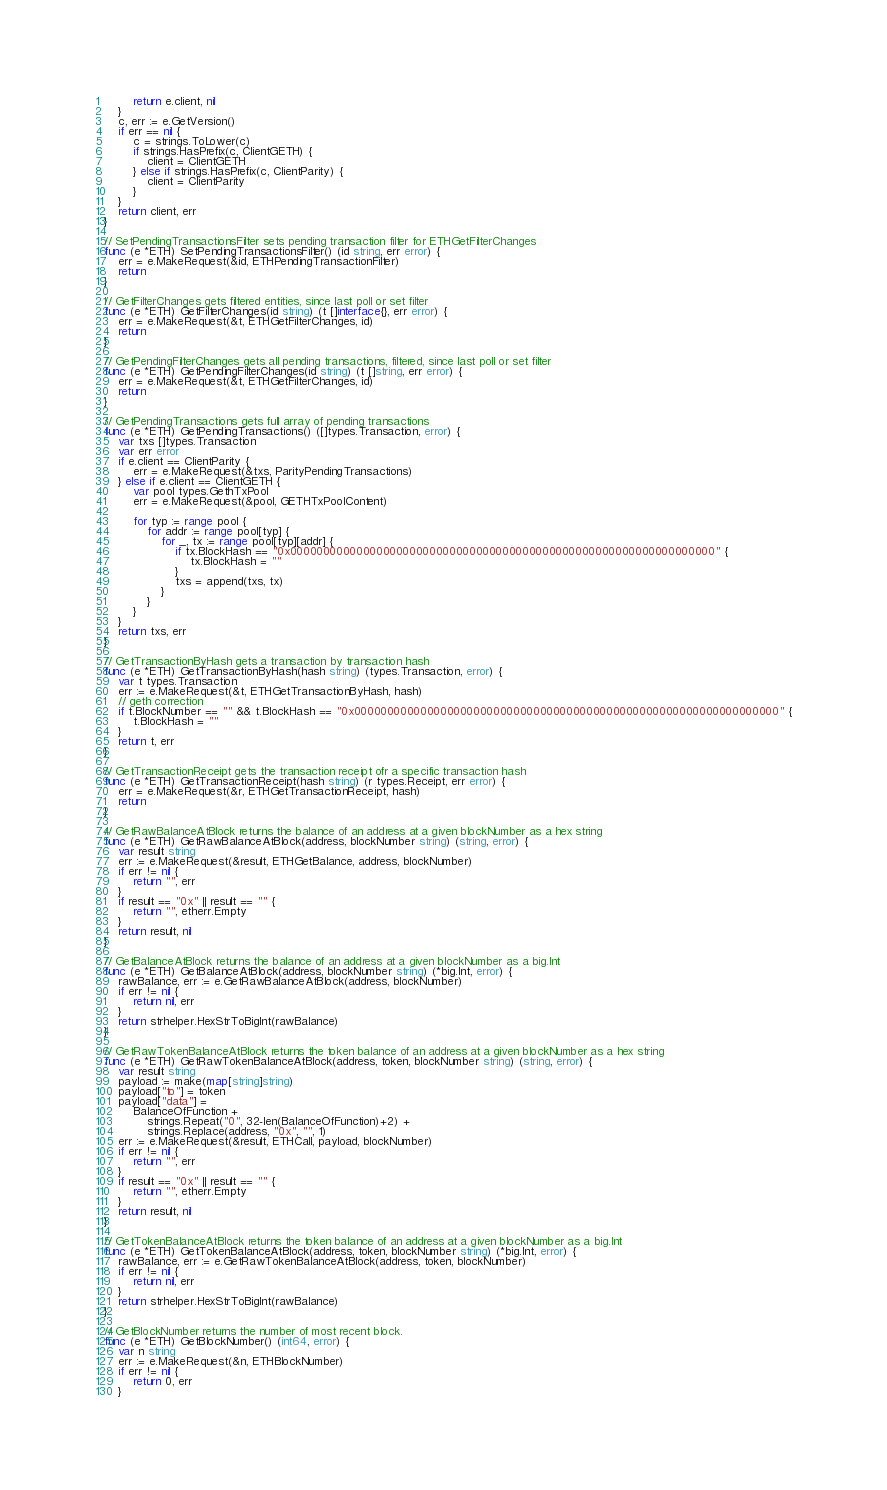Convert code to text. <code><loc_0><loc_0><loc_500><loc_500><_Go_>		return e.client, nil
	}
	c, err := e.GetVersion()
	if err == nil {
		c = strings.ToLower(c)
		if strings.HasPrefix(c, ClientGETH) {
			client = ClientGETH
		} else if strings.HasPrefix(c, ClientParity) {
			client = ClientParity
		}
	}
	return client, err
}

// SetPendingTransactionsFilter sets pending transaction filter for ETHGetFilterChanges
func (e *ETH) SetPendingTransactionsFilter() (id string, err error) {
	err = e.MakeRequest(&id, ETHPendingTransactionFilter)
	return
}

// GetFilterChanges gets filtered entities, since last poll or set filter
func (e *ETH) GetFilterChanges(id string) (t []interface{}, err error) {
	err = e.MakeRequest(&t, ETHGetFilterChanges, id)
	return
}

// GetPendingFilterChanges gets all pending transactions, filtered, since last poll or set filter
func (e *ETH) GetPendingFilterChanges(id string) (t []string, err error) {
	err = e.MakeRequest(&t, ETHGetFilterChanges, id)
	return
}

// GetPendingTransactions gets full array of pending transactions
func (e *ETH) GetPendingTransactions() ([]types.Transaction, error) {
	var txs []types.Transaction
	var err error
	if e.client == ClientParity {
		err = e.MakeRequest(&txs, ParityPendingTransactions)
	} else if e.client == ClientGETH {
		var pool types.GethTxPool
		err = e.MakeRequest(&pool, GETHTxPoolContent)

		for typ := range pool {
			for addr := range pool[typ] {
				for _, tx := range pool[typ][addr] {
					if tx.BlockHash == "0x0000000000000000000000000000000000000000000000000000000000000000" {
						tx.BlockHash = ""
					}
					txs = append(txs, tx)
				}
			}
		}
	}
	return txs, err
}

// GetTransactionByHash gets a transaction by transaction hash
func (e *ETH) GetTransactionByHash(hash string) (types.Transaction, error) {
	var t types.Transaction
	err := e.MakeRequest(&t, ETHGetTransactionByHash, hash)
	// geth correction
	if t.BlockNumber == "" && t.BlockHash == "0x0000000000000000000000000000000000000000000000000000000000000000" {
		t.BlockHash = ""
	}
	return t, err
}

// GetTransactionReceipt gets the transaction receipt ofr a specific transaction hash
func (e *ETH) GetTransactionReceipt(hash string) (r types.Receipt, err error) {
	err = e.MakeRequest(&r, ETHGetTransactionReceipt, hash)
	return
}

// GetRawBalanceAtBlock returns the balance of an address at a given blockNumber as a hex string
func (e *ETH) GetRawBalanceAtBlock(address, blockNumber string) (string, error) {
	var result string
	err := e.MakeRequest(&result, ETHGetBalance, address, blockNumber)
	if err != nil {
		return "", err
	}
	if result == "0x" || result == "" {
		return "", etherr.Empty
	}
	return result, nil
}

// GetBalanceAtBlock returns the balance of an address at a given blockNumber as a big.Int
func (e *ETH) GetBalanceAtBlock(address, blockNumber string) (*big.Int, error) {
	rawBalance, err := e.GetRawBalanceAtBlock(address, blockNumber)
	if err != nil {
		return nil, err
	}
	return strhelper.HexStrToBigInt(rawBalance)
}

// GetRawTokenBalanceAtBlock returns the token balance of an address at a given blockNumber as a hex string
func (e *ETH) GetRawTokenBalanceAtBlock(address, token, blockNumber string) (string, error) {
	var result string
	payload := make(map[string]string)
	payload["to"] = token
	payload["data"] =
		BalanceOfFunction +
			strings.Repeat("0", 32-len(BalanceOfFunction)+2) +
			strings.Replace(address, "0x", "", 1)
	err := e.MakeRequest(&result, ETHCall, payload, blockNumber)
	if err != nil {
		return "", err
	}
	if result == "0x" || result == "" {
		return "", etherr.Empty
	}
	return result, nil
}

// GetTokenBalanceAtBlock returns the token balance of an address at a given blockNumber as a big.Int
func (e *ETH) GetTokenBalanceAtBlock(address, token, blockNumber string) (*big.Int, error) {
	rawBalance, err := e.GetRawTokenBalanceAtBlock(address, token, blockNumber)
	if err != nil {
		return nil, err
	}
	return strhelper.HexStrToBigInt(rawBalance)
}

// GetBlockNumber returns the number of most recent block.
func (e *ETH) GetBlockNumber() (int64, error) {
	var n string
	err := e.MakeRequest(&n, ETHBlockNumber)
	if err != nil {
		return 0, err
	}</code> 